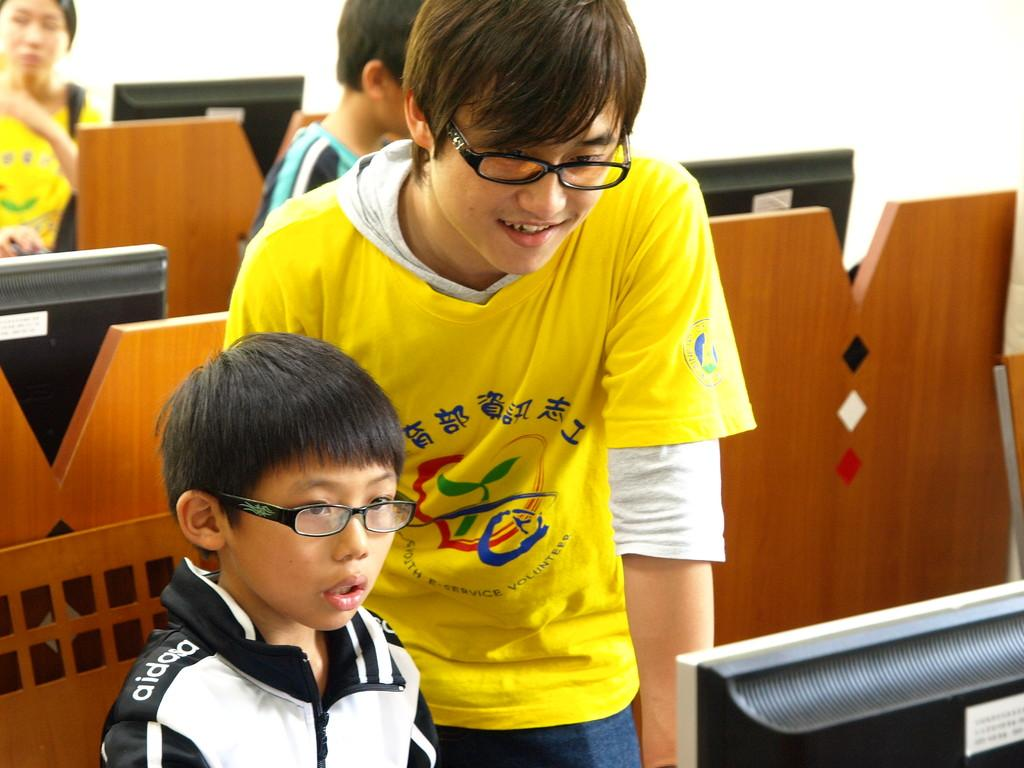Who is present in the image? There is a man and a boy in the image. What do the man and the boy have in common? Both the man and the boy are wearing glasses. What object is in front of them? There is a computer in front of them. What can be seen in the background of the image? There is a table in the background. What is on the table in the background? There are computers on the table in the background. What type of game are the children playing in the image? There are no children present in the image, only a man and a boy. Additionally, there is no game being played in the image. 